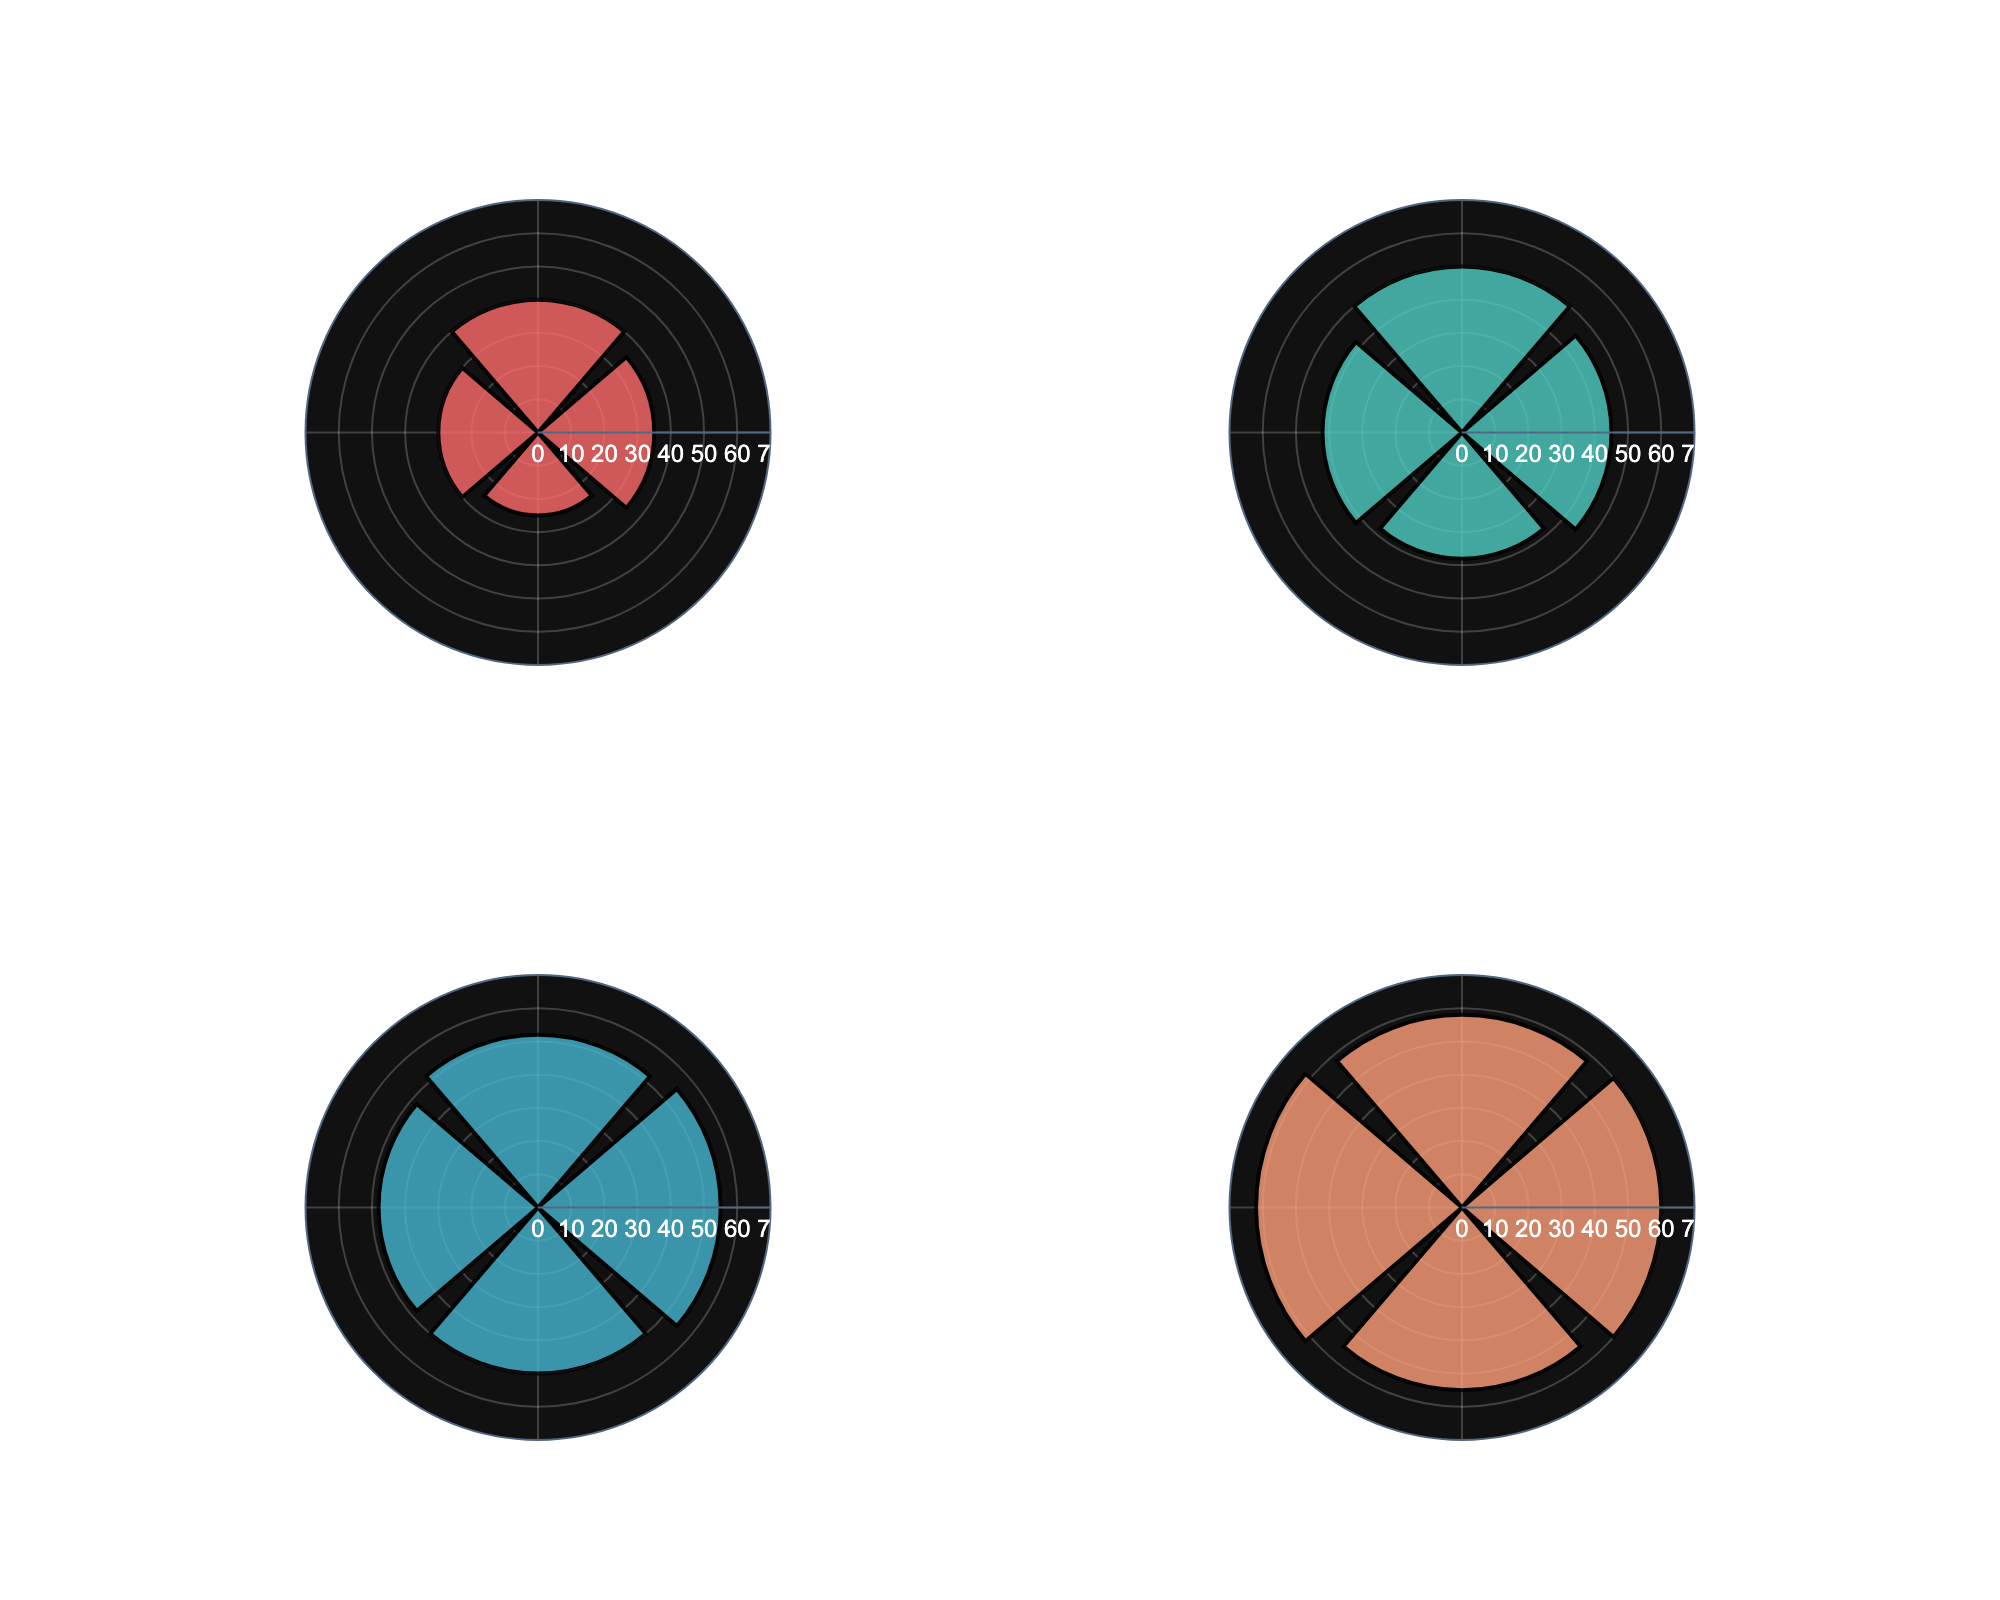What is the title of the figure? The title of the figure is displayed at the top. It reads "Distribution of Media Outreach Success Rates by Channel."
Answer: Distribution of Media Outreach Success Rates by Channel Which media channel subplot has the highest success rate? To find the highest success rate, look at each subplot and identify the highest value. The highest success rate is found in the Broadcast subplot for NBC with a rate of 62.
Answer: Broadcast Which company has the lowest success rate in the Print media channel? Examine the "Print" subplot and check the values of each company. The lowest success rate in this channel is for Bloomberg Businessweek with a rate of 25.
Answer: Bloomberg Businessweek How many media channels are represented in the figure? Count the number of subplot titles. There are four titles: Print, Online, Social Media, and Broadcast.
Answer: 4 What is the average success rate of the Online media channel? Sum the success rates of the companies in the Online channel, then divide by the number of companies. (45 + 50 + 42 + 38) / 4 = 43.75
Answer: 43.75 Compare the highest success rates of Social Media and Print media channels. Which one is higher and by how much? Identify the highest success rates in Social Media (Twitter, 55) and Print (The New York Times, 40). Subtract the highest Print rate from the highest Social Media rate: 55 - 40 = 15.
Answer: Social Media is higher by 15 What is the range of success rates in the Broadcast media channel? The range is found by subtracting the lowest success rate in the Broadcast subplot (Bloomberg TV, 55) from the highest (NBC, 62): 62 - 55 = 7.
Answer: 7 Which Social Media company has the median success rate? List the success rates of Social Media companies in ascending order (48, 50, 50, 55) and find the median. The median is the average of the two middle values (50 and 50), so the median success rate is 50, shared by LinkedIn and Instagram.
Answer: LinkedIn and Instagram What is the combined success rate of all companies in the Print and Broadcast media channels? Sum the success rates of companies in both the Print and Broadcast channels. Print: 35 + 40 + 30 + 25 = 130, Broadcast: 60 + 58 + 62 + 55 = 235. Combined: 130 + 235 = 365.
Answer: 365 Which media channel exhibits the most varied success rates among its companies? Assess the range of success rates (highest minus lowest) within each subplot. Print has a range of 15 (40-25), Online has a range of 12 (50-38), Social Media has a range of 7 (55-48), Broadcast has a range of 7 (62-55). The Print channel exhibits the most varied success rates.
Answer: Print 